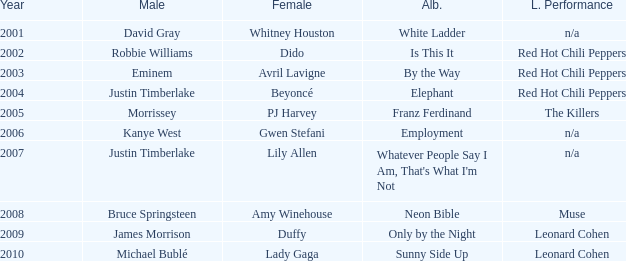Which female artist has an album named elephant? Beyoncé. 